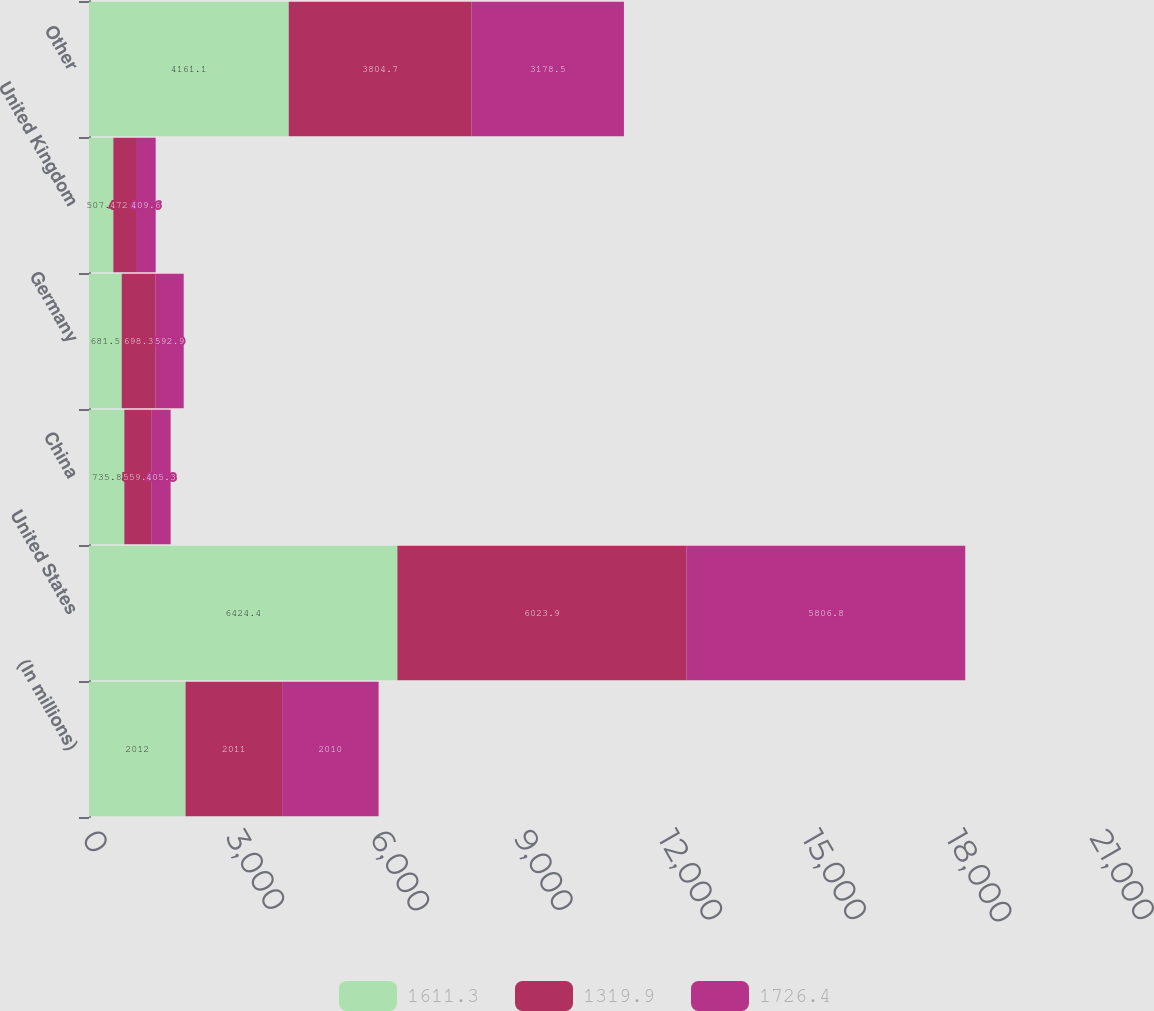Convert chart. <chart><loc_0><loc_0><loc_500><loc_500><stacked_bar_chart><ecel><fcel>(In millions)<fcel>United States<fcel>China<fcel>Germany<fcel>United Kingdom<fcel>Other<nl><fcel>1611.3<fcel>2012<fcel>6424.4<fcel>735.8<fcel>681.5<fcel>507.1<fcel>4161.1<nl><fcel>1319.9<fcel>2011<fcel>6023.9<fcel>559.6<fcel>698.3<fcel>472.3<fcel>3804.7<nl><fcel>1726.4<fcel>2010<fcel>5806.8<fcel>405.3<fcel>592.9<fcel>409.6<fcel>3178.5<nl></chart> 